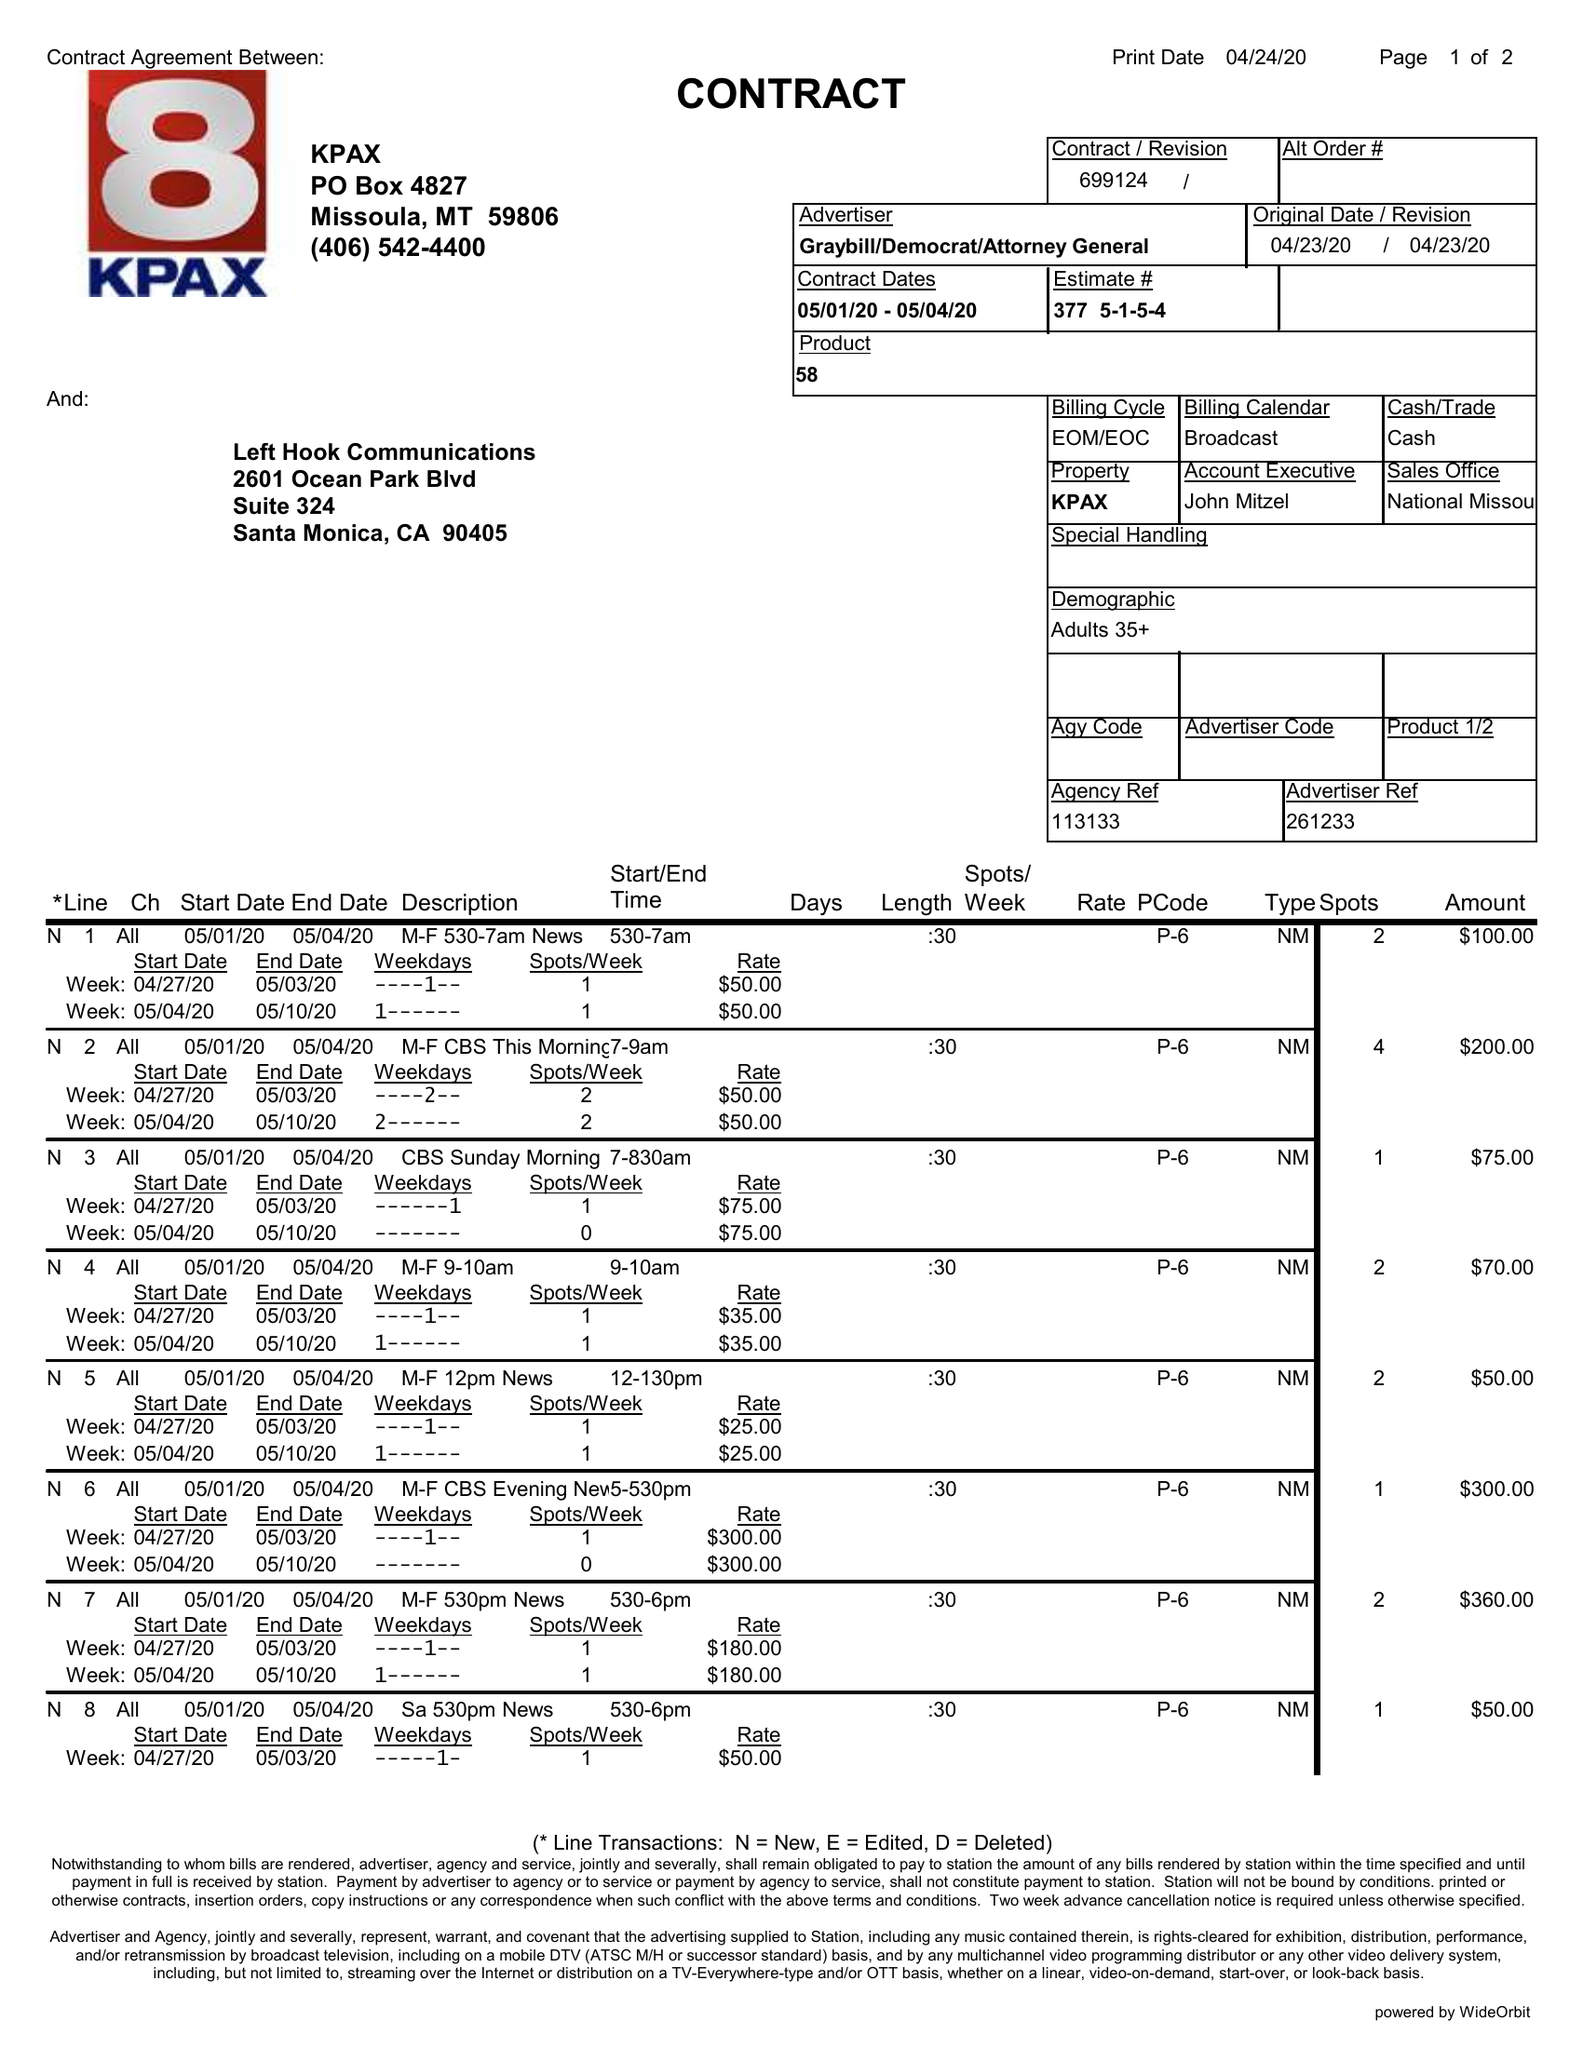What is the value for the advertiser?
Answer the question using a single word or phrase. GRAYBILL/DEMOCRAT/ATTORNEYGENERAL 